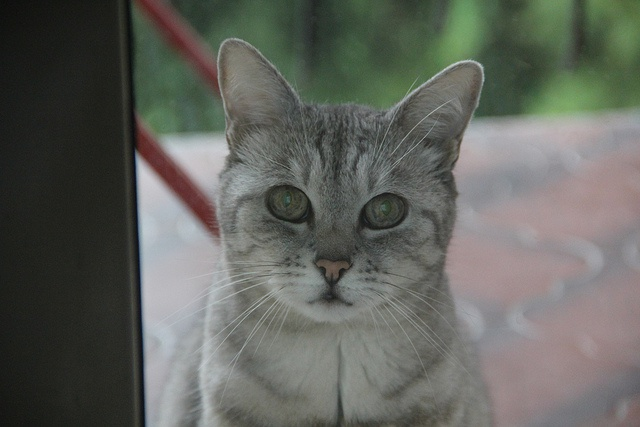Describe the objects in this image and their specific colors. I can see a cat in black, gray, and darkgray tones in this image. 